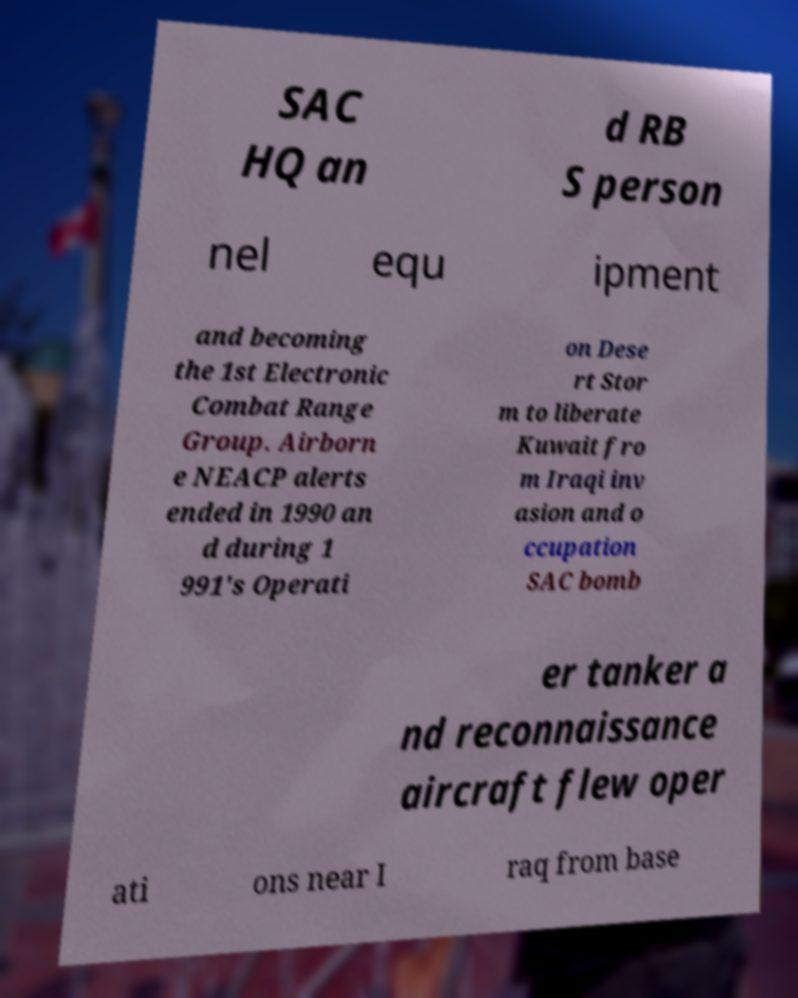Please identify and transcribe the text found in this image. SAC HQ an d RB S person nel equ ipment and becoming the 1st Electronic Combat Range Group. Airborn e NEACP alerts ended in 1990 an d during 1 991's Operati on Dese rt Stor m to liberate Kuwait fro m Iraqi inv asion and o ccupation SAC bomb er tanker a nd reconnaissance aircraft flew oper ati ons near I raq from base 